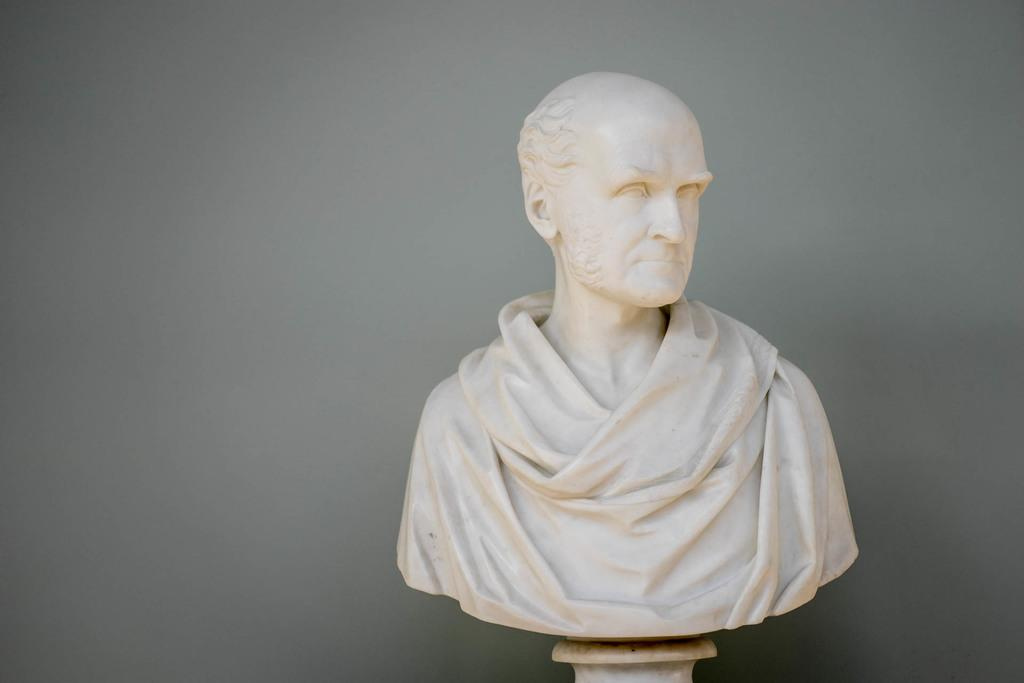What is the main subject in the center of the image? There is a sculpture in the center of the image. What can be seen in the background of the image? There is a grey color wall in the background of the image. What type of bag is being used to carry the sculpture in the image? There is no bag present in the image, and the sculpture is not being carried. 